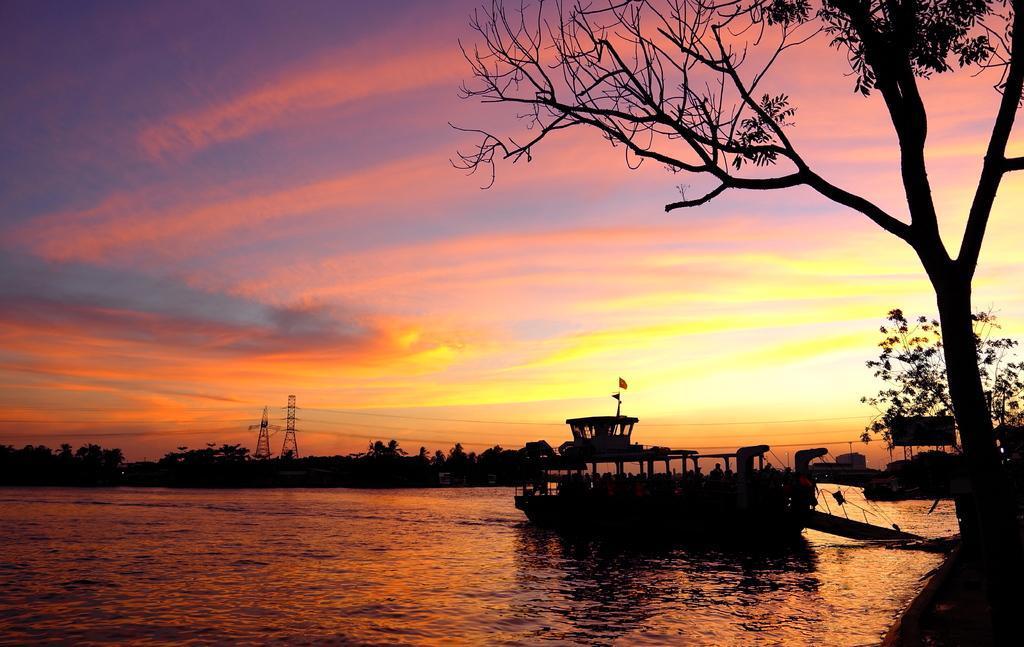Could you give a brief overview of what you see in this image? In this image we can see a ship on the river, there are trees, towers, wires, also we can see the sky. 